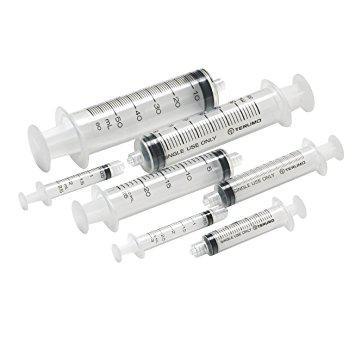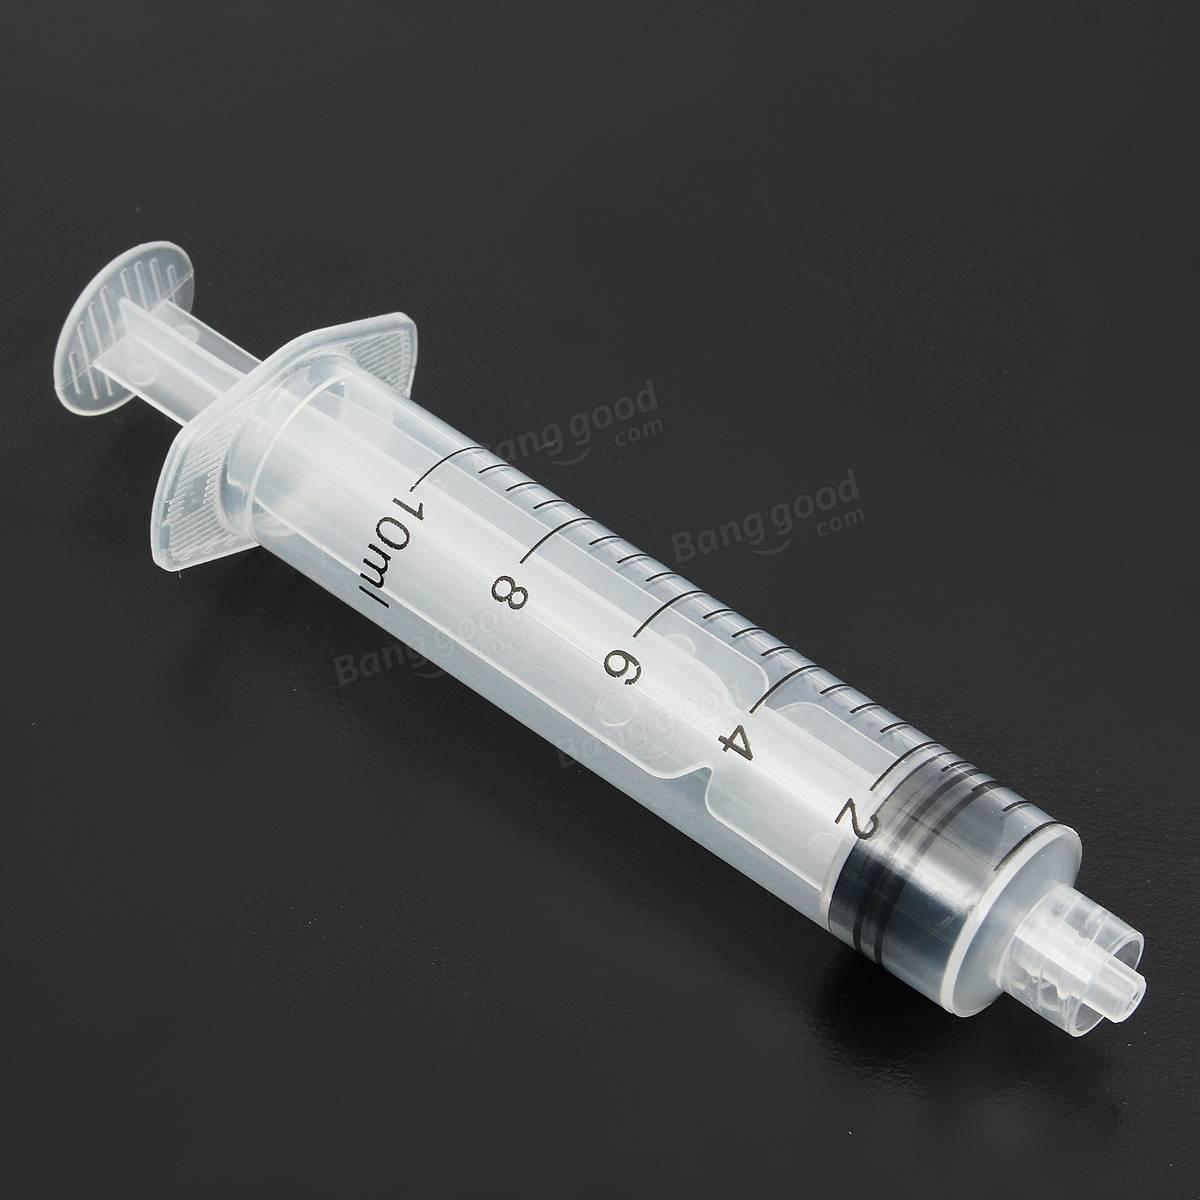The first image is the image on the left, the second image is the image on the right. Given the left and right images, does the statement "The right image shows a single syringe angled with its tip at the lower right." hold true? Answer yes or no. Yes. 